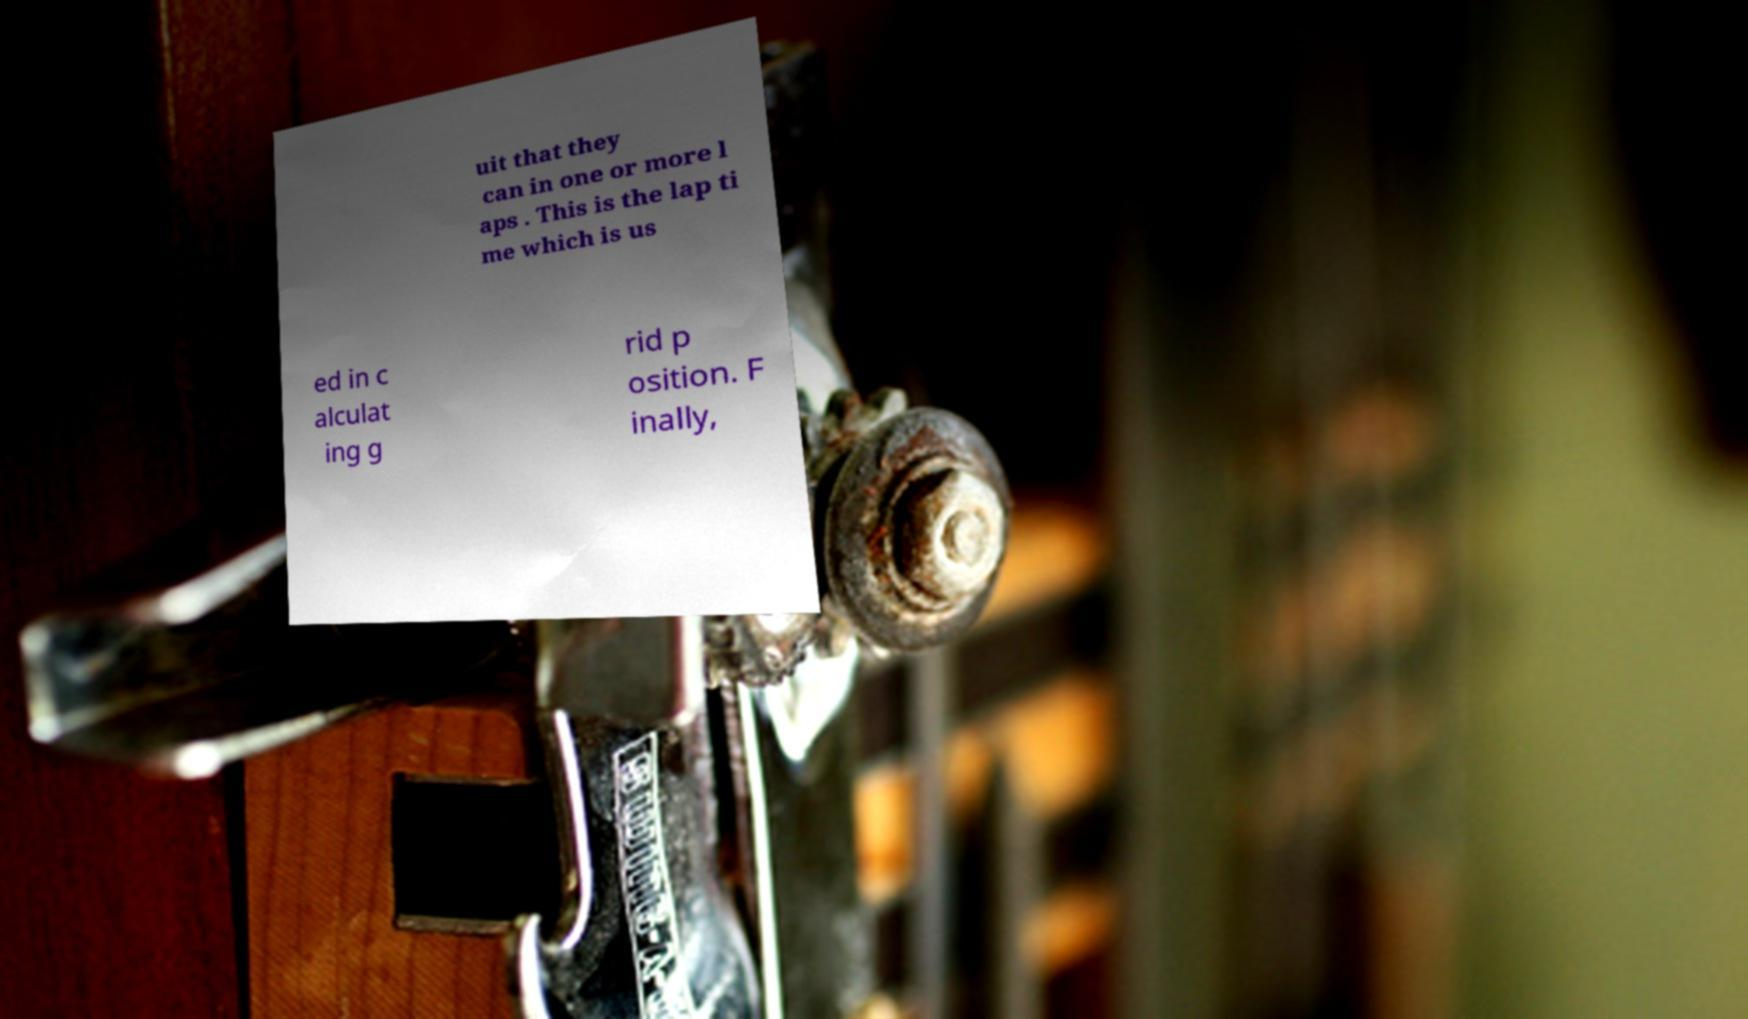Can you accurately transcribe the text from the provided image for me? uit that they can in one or more l aps . This is the lap ti me which is us ed in c alculat ing g rid p osition. F inally, 